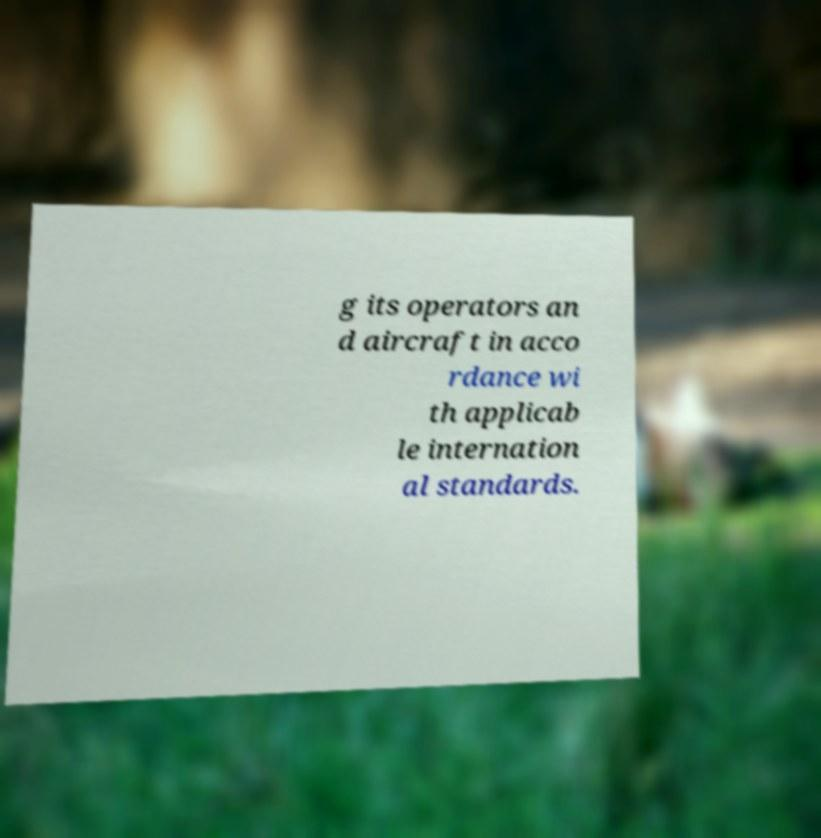Can you accurately transcribe the text from the provided image for me? g its operators an d aircraft in acco rdance wi th applicab le internation al standards. 